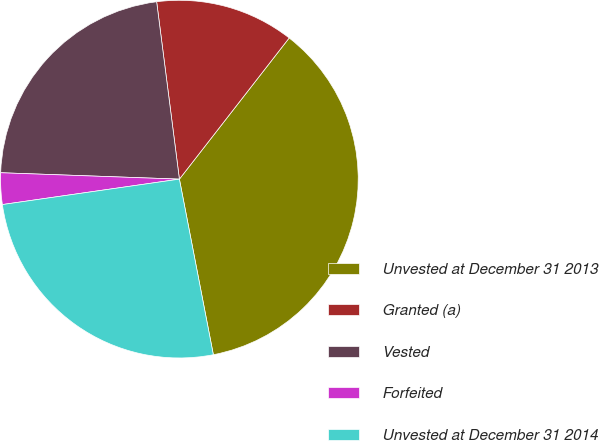Convert chart. <chart><loc_0><loc_0><loc_500><loc_500><pie_chart><fcel>Unvested at December 31 2013<fcel>Granted (a)<fcel>Vested<fcel>Forfeited<fcel>Unvested at December 31 2014<nl><fcel>36.44%<fcel>12.55%<fcel>22.4%<fcel>2.84%<fcel>25.77%<nl></chart> 